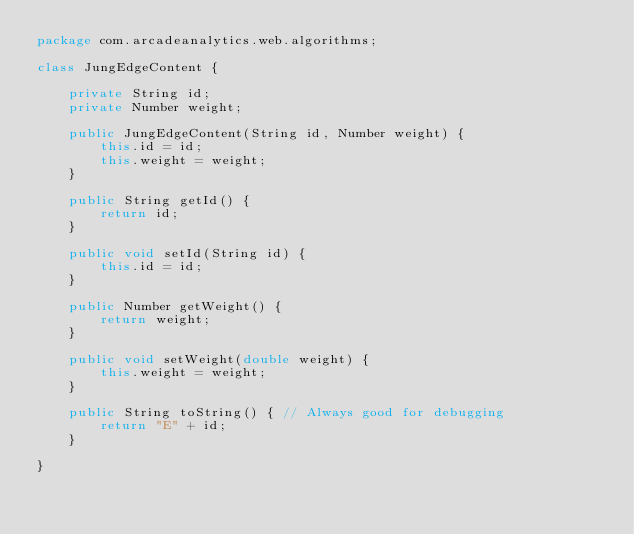<code> <loc_0><loc_0><loc_500><loc_500><_Java_>package com.arcadeanalytics.web.algorithms;

class JungEdgeContent {

    private String id;
    private Number weight;

    public JungEdgeContent(String id, Number weight) {
        this.id = id;
        this.weight = weight;
    }

    public String getId() {
        return id;
    }

    public void setId(String id) {
        this.id = id;
    }

    public Number getWeight() {
        return weight;
    }

    public void setWeight(double weight) {
        this.weight = weight;
    }

    public String toString() { // Always good for debugging
        return "E" + id;
    }

}</code> 